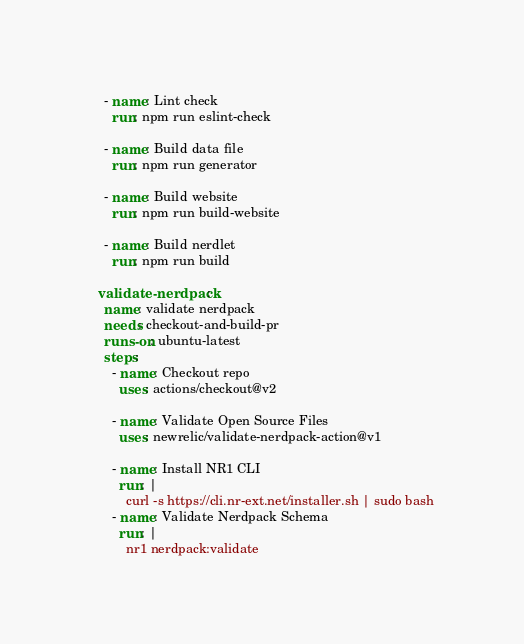Convert code to text. <code><loc_0><loc_0><loc_500><loc_500><_YAML_>    - name: Lint check
      run: npm run eslint-check

    - name: Build data file
      run: npm run generator

    - name: Build website
      run: npm run build-website

    - name: Build nerdlet
      run: npm run build

  validate-nerdpack:
    name: validate nerdpack
    needs: checkout-and-build-pr
    runs-on: ubuntu-latest
    steps:
      - name: Checkout repo
        uses: actions/checkout@v2

      - name: Validate Open Source Files
        uses: newrelic/validate-nerdpack-action@v1

      - name: Install NR1 CLI
        run: |
          curl -s https://cli.nr-ext.net/installer.sh | sudo bash
      - name: Validate Nerdpack Schema
        run: |
          nr1 nerdpack:validate
</code> 